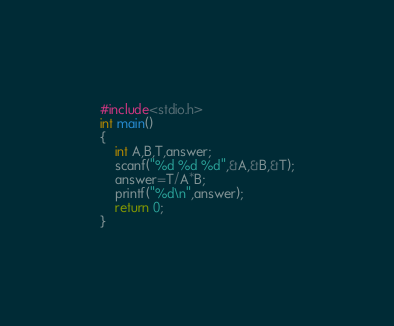Convert code to text. <code><loc_0><loc_0><loc_500><loc_500><_C_>#include<stdio.h>
int main()
{
    int A,B,T,answer;
    scanf("%d %d %d",&A,&B,&T);
    answer=T/A*B;
    printf("%d\n",answer);
    return 0;
}
</code> 